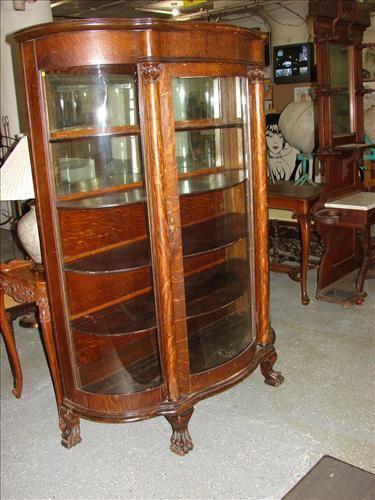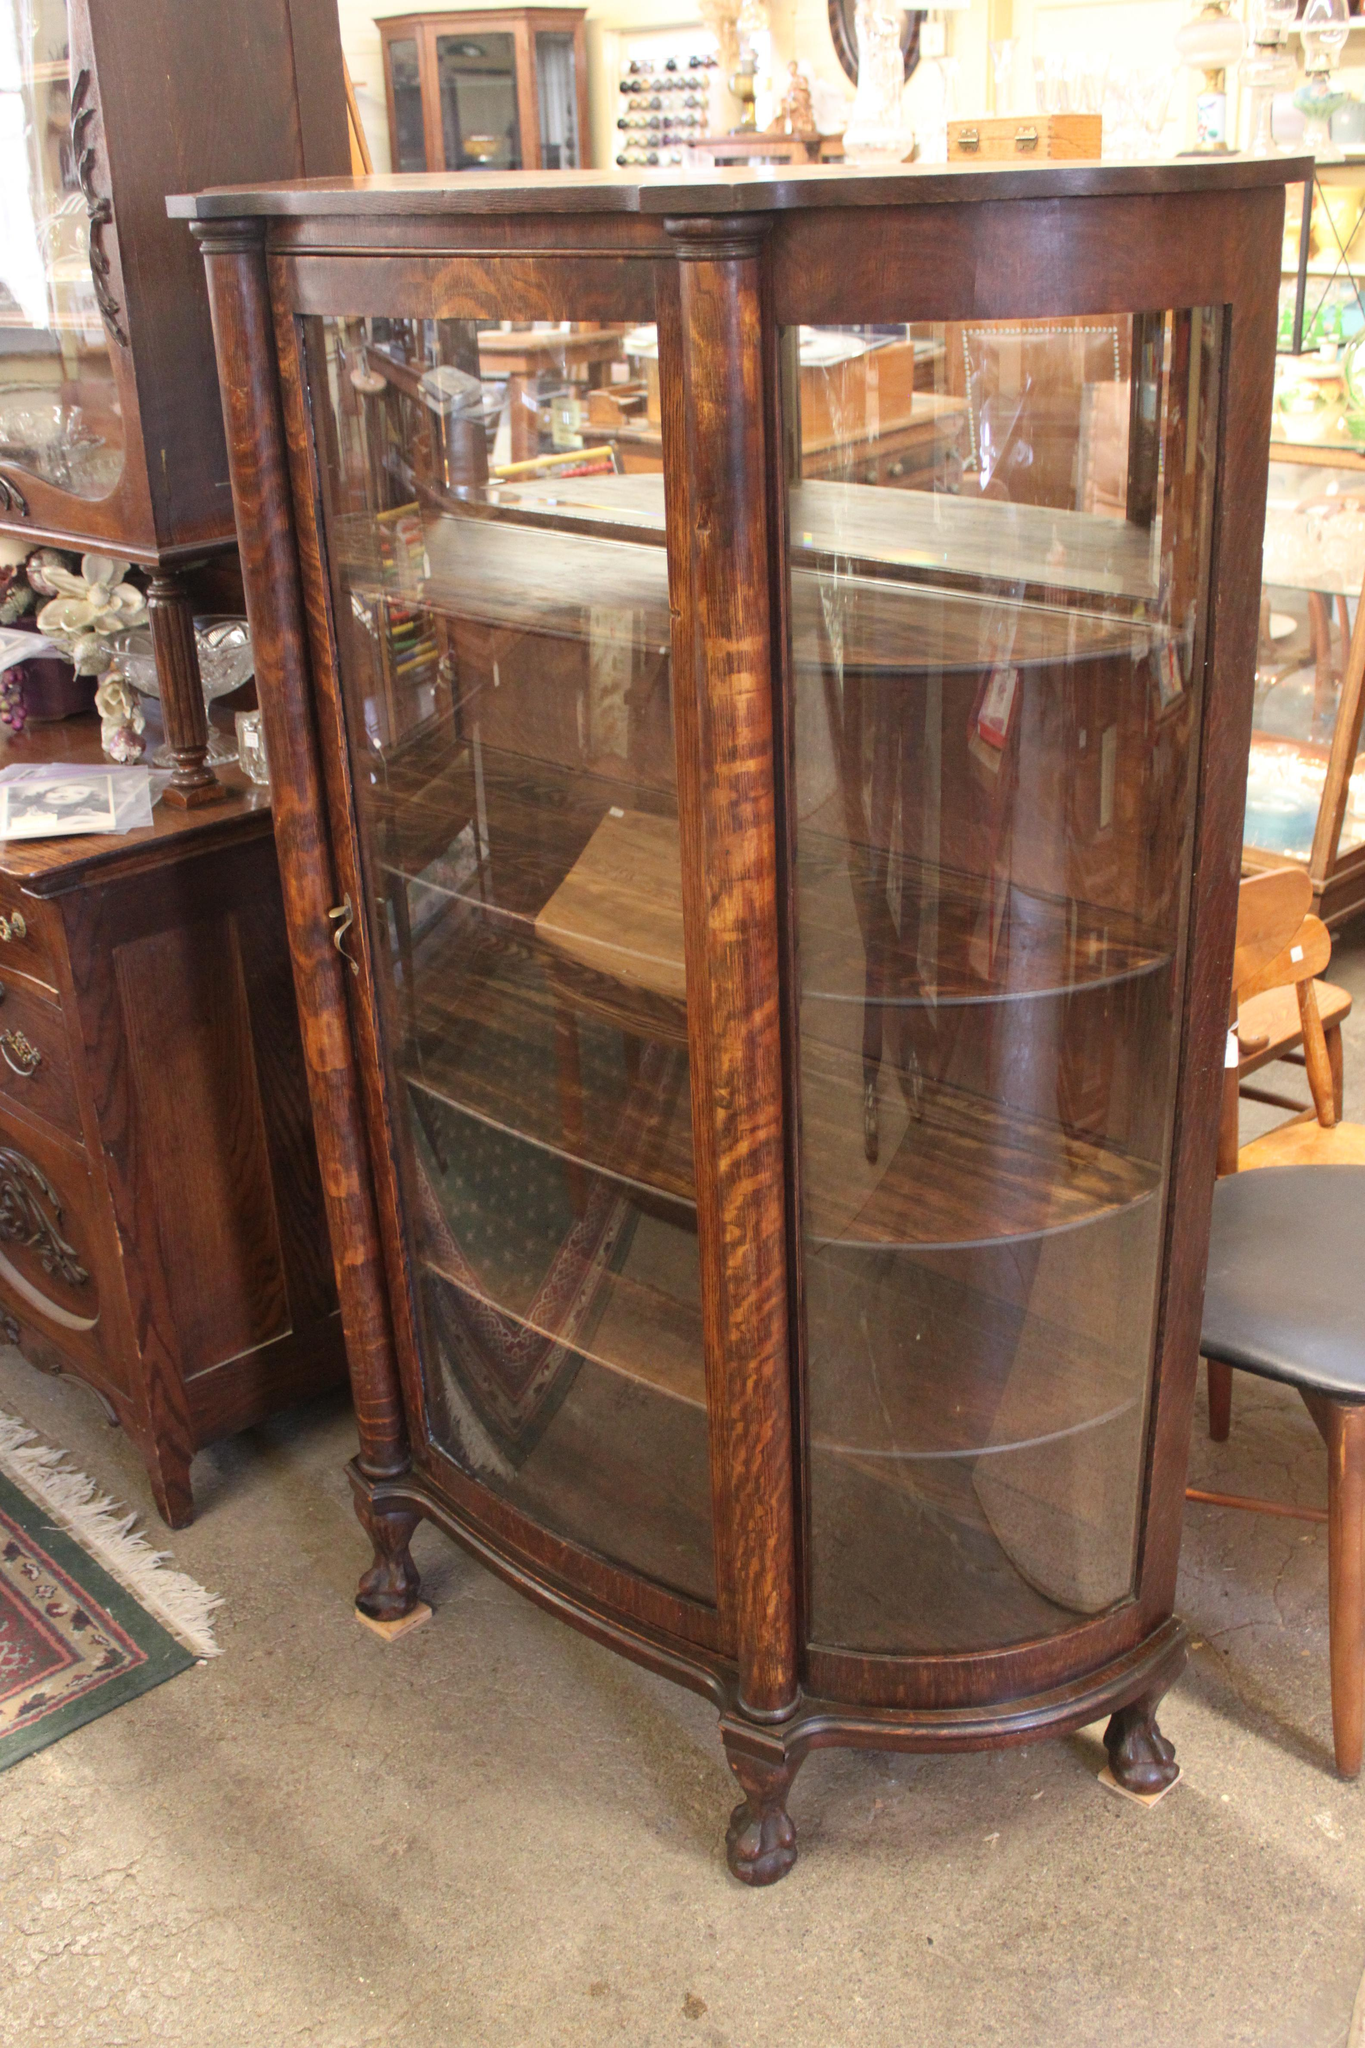The first image is the image on the left, the second image is the image on the right. For the images shown, is this caption "There are two empty wooden curio cabinets with glass fronts." true? Answer yes or no. Yes. The first image is the image on the left, the second image is the image on the right. For the images shown, is this caption "There are two wood and glass cabinets, and they are both empty." true? Answer yes or no. Yes. 